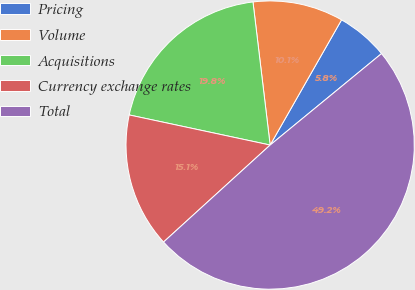<chart> <loc_0><loc_0><loc_500><loc_500><pie_chart><fcel>Pricing<fcel>Volume<fcel>Acquisitions<fcel>Currency exchange rates<fcel>Total<nl><fcel>5.81%<fcel>10.15%<fcel>19.75%<fcel>15.1%<fcel>49.19%<nl></chart> 